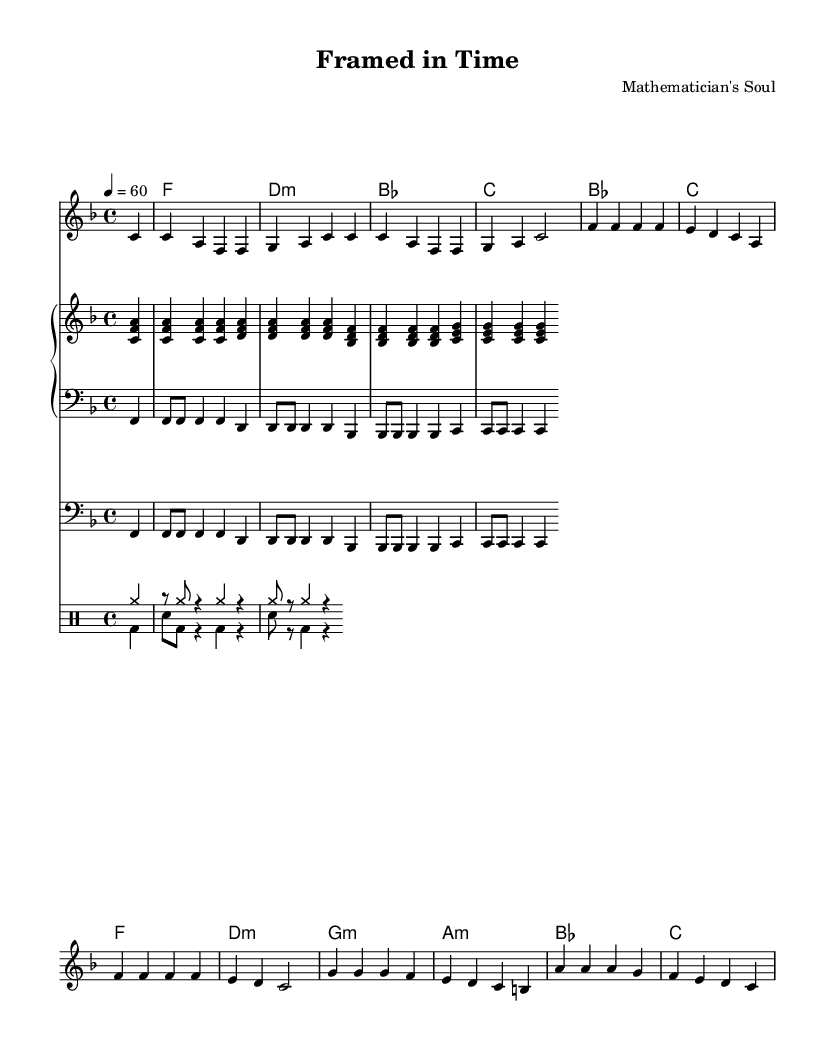What is the key signature of this music? The key signature is F major, which has one flat (B flat). This is indicated by the key signature at the beginning of the staff.
Answer: F major What is the time signature of this music? The time signature is 4/4, which is indicated at the beginning of the piece. It implies four beats per measure with each beat being a quarter note.
Answer: 4/4 What is the tempo marking? The tempo marking is 60 beats per minute, which is indicated in the score. This means that there are 60 quarter note beats in one minute.
Answer: 60 How many measures are in the melody? Count the measures indicated by the vertical bar lines in the melody. There are 8 measures in total in the provided melody segment.
Answer: 8 What type of music form is indicated by the lyrics? The lyrics follow a verse structure, reflecting the soul genre's typical storytelling approach about capturing moments and emotions through photography.
Answer: Verse Which instrument plays the electric bass part? The electric bass is indicated by the staff labeled as "bass" in the score. It plays a harmonic role along with the piano and drums.
Answer: Electric bass What chord follows the lyric line "Math and art break down the walls"? The chords above this lyric line indicate that the chord is D minor, which provides a minor tonality that complements the soulful theme of the lyrics.
Answer: D minor 